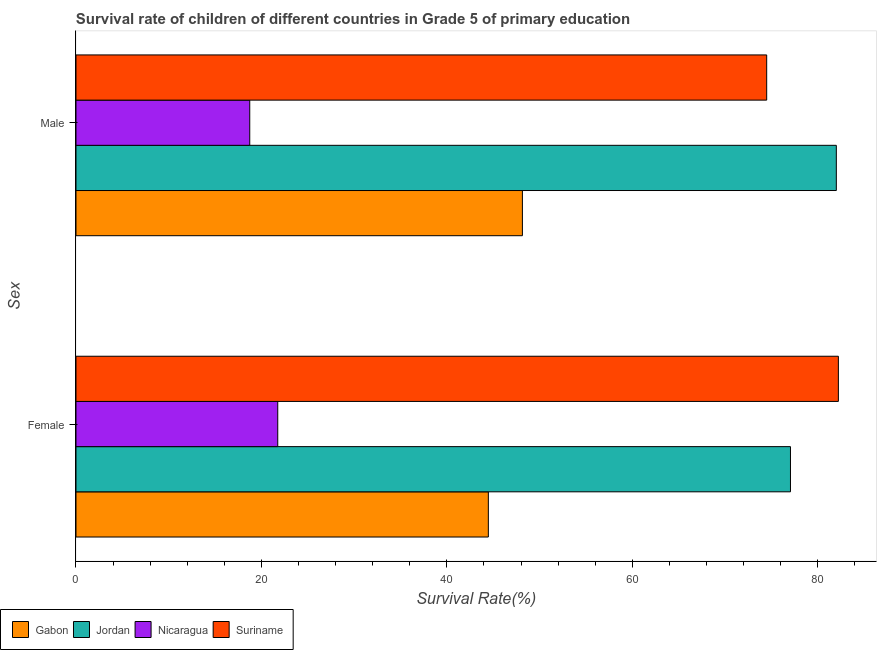How many groups of bars are there?
Provide a short and direct response. 2. Are the number of bars per tick equal to the number of legend labels?
Your answer should be very brief. Yes. Are the number of bars on each tick of the Y-axis equal?
Your response must be concise. Yes. How many bars are there on the 1st tick from the bottom?
Your response must be concise. 4. What is the survival rate of female students in primary education in Jordan?
Ensure brevity in your answer.  77.06. Across all countries, what is the maximum survival rate of male students in primary education?
Give a very brief answer. 82.01. Across all countries, what is the minimum survival rate of male students in primary education?
Keep it short and to the point. 18.74. In which country was the survival rate of male students in primary education maximum?
Give a very brief answer. Jordan. In which country was the survival rate of male students in primary education minimum?
Make the answer very short. Nicaragua. What is the total survival rate of male students in primary education in the graph?
Give a very brief answer. 223.4. What is the difference between the survival rate of male students in primary education in Gabon and that in Nicaragua?
Make the answer very short. 29.41. What is the difference between the survival rate of female students in primary education in Suriname and the survival rate of male students in primary education in Nicaragua?
Keep it short and to the point. 63.49. What is the average survival rate of female students in primary education per country?
Your response must be concise. 56.38. What is the difference between the survival rate of female students in primary education and survival rate of male students in primary education in Gabon?
Provide a short and direct response. -3.67. In how many countries, is the survival rate of female students in primary education greater than 28 %?
Ensure brevity in your answer.  3. What is the ratio of the survival rate of male students in primary education in Nicaragua to that in Suriname?
Ensure brevity in your answer.  0.25. In how many countries, is the survival rate of male students in primary education greater than the average survival rate of male students in primary education taken over all countries?
Provide a succinct answer. 2. What does the 1st bar from the top in Male represents?
Ensure brevity in your answer.  Suriname. What does the 4th bar from the bottom in Male represents?
Provide a short and direct response. Suriname. How many bars are there?
Your answer should be very brief. 8. Are all the bars in the graph horizontal?
Your answer should be compact. Yes. How many countries are there in the graph?
Your answer should be very brief. 4. What is the difference between two consecutive major ticks on the X-axis?
Ensure brevity in your answer.  20. Are the values on the major ticks of X-axis written in scientific E-notation?
Offer a very short reply. No. How many legend labels are there?
Provide a succinct answer. 4. What is the title of the graph?
Your response must be concise. Survival rate of children of different countries in Grade 5 of primary education. Does "Mongolia" appear as one of the legend labels in the graph?
Your response must be concise. No. What is the label or title of the X-axis?
Provide a succinct answer. Survival Rate(%). What is the label or title of the Y-axis?
Offer a very short reply. Sex. What is the Survival Rate(%) in Gabon in Female?
Keep it short and to the point. 44.48. What is the Survival Rate(%) in Jordan in Female?
Your answer should be compact. 77.06. What is the Survival Rate(%) in Nicaragua in Female?
Your answer should be very brief. 21.76. What is the Survival Rate(%) in Suriname in Female?
Keep it short and to the point. 82.23. What is the Survival Rate(%) in Gabon in Male?
Offer a terse response. 48.15. What is the Survival Rate(%) in Jordan in Male?
Your answer should be very brief. 82.01. What is the Survival Rate(%) in Nicaragua in Male?
Give a very brief answer. 18.74. What is the Survival Rate(%) in Suriname in Male?
Your response must be concise. 74.5. Across all Sex, what is the maximum Survival Rate(%) of Gabon?
Ensure brevity in your answer.  48.15. Across all Sex, what is the maximum Survival Rate(%) of Jordan?
Your answer should be very brief. 82.01. Across all Sex, what is the maximum Survival Rate(%) in Nicaragua?
Provide a short and direct response. 21.76. Across all Sex, what is the maximum Survival Rate(%) in Suriname?
Your answer should be compact. 82.23. Across all Sex, what is the minimum Survival Rate(%) of Gabon?
Keep it short and to the point. 44.48. Across all Sex, what is the minimum Survival Rate(%) in Jordan?
Offer a very short reply. 77.06. Across all Sex, what is the minimum Survival Rate(%) of Nicaragua?
Your response must be concise. 18.74. Across all Sex, what is the minimum Survival Rate(%) of Suriname?
Offer a terse response. 74.5. What is the total Survival Rate(%) in Gabon in the graph?
Provide a short and direct response. 92.62. What is the total Survival Rate(%) in Jordan in the graph?
Keep it short and to the point. 159.07. What is the total Survival Rate(%) in Nicaragua in the graph?
Keep it short and to the point. 40.5. What is the total Survival Rate(%) in Suriname in the graph?
Provide a short and direct response. 156.72. What is the difference between the Survival Rate(%) in Gabon in Female and that in Male?
Offer a very short reply. -3.67. What is the difference between the Survival Rate(%) in Jordan in Female and that in Male?
Your answer should be compact. -4.95. What is the difference between the Survival Rate(%) in Nicaragua in Female and that in Male?
Your response must be concise. 3.02. What is the difference between the Survival Rate(%) of Suriname in Female and that in Male?
Your answer should be compact. 7.73. What is the difference between the Survival Rate(%) in Gabon in Female and the Survival Rate(%) in Jordan in Male?
Keep it short and to the point. -37.53. What is the difference between the Survival Rate(%) of Gabon in Female and the Survival Rate(%) of Nicaragua in Male?
Your answer should be compact. 25.73. What is the difference between the Survival Rate(%) of Gabon in Female and the Survival Rate(%) of Suriname in Male?
Your answer should be very brief. -30.02. What is the difference between the Survival Rate(%) in Jordan in Female and the Survival Rate(%) in Nicaragua in Male?
Ensure brevity in your answer.  58.32. What is the difference between the Survival Rate(%) in Jordan in Female and the Survival Rate(%) in Suriname in Male?
Provide a short and direct response. 2.57. What is the difference between the Survival Rate(%) of Nicaragua in Female and the Survival Rate(%) of Suriname in Male?
Your answer should be compact. -52.73. What is the average Survival Rate(%) in Gabon per Sex?
Your response must be concise. 46.31. What is the average Survival Rate(%) in Jordan per Sex?
Provide a succinct answer. 79.54. What is the average Survival Rate(%) in Nicaragua per Sex?
Give a very brief answer. 20.25. What is the average Survival Rate(%) in Suriname per Sex?
Ensure brevity in your answer.  78.36. What is the difference between the Survival Rate(%) in Gabon and Survival Rate(%) in Jordan in Female?
Provide a succinct answer. -32.59. What is the difference between the Survival Rate(%) of Gabon and Survival Rate(%) of Nicaragua in Female?
Give a very brief answer. 22.71. What is the difference between the Survival Rate(%) in Gabon and Survival Rate(%) in Suriname in Female?
Ensure brevity in your answer.  -37.75. What is the difference between the Survival Rate(%) of Jordan and Survival Rate(%) of Nicaragua in Female?
Your response must be concise. 55.3. What is the difference between the Survival Rate(%) in Jordan and Survival Rate(%) in Suriname in Female?
Keep it short and to the point. -5.17. What is the difference between the Survival Rate(%) in Nicaragua and Survival Rate(%) in Suriname in Female?
Give a very brief answer. -60.47. What is the difference between the Survival Rate(%) of Gabon and Survival Rate(%) of Jordan in Male?
Offer a very short reply. -33.86. What is the difference between the Survival Rate(%) of Gabon and Survival Rate(%) of Nicaragua in Male?
Give a very brief answer. 29.41. What is the difference between the Survival Rate(%) of Gabon and Survival Rate(%) of Suriname in Male?
Make the answer very short. -26.35. What is the difference between the Survival Rate(%) of Jordan and Survival Rate(%) of Nicaragua in Male?
Provide a short and direct response. 63.27. What is the difference between the Survival Rate(%) of Jordan and Survival Rate(%) of Suriname in Male?
Your answer should be compact. 7.51. What is the difference between the Survival Rate(%) in Nicaragua and Survival Rate(%) in Suriname in Male?
Your response must be concise. -55.75. What is the ratio of the Survival Rate(%) of Gabon in Female to that in Male?
Provide a short and direct response. 0.92. What is the ratio of the Survival Rate(%) of Jordan in Female to that in Male?
Offer a terse response. 0.94. What is the ratio of the Survival Rate(%) of Nicaragua in Female to that in Male?
Ensure brevity in your answer.  1.16. What is the ratio of the Survival Rate(%) of Suriname in Female to that in Male?
Ensure brevity in your answer.  1.1. What is the difference between the highest and the second highest Survival Rate(%) of Gabon?
Ensure brevity in your answer.  3.67. What is the difference between the highest and the second highest Survival Rate(%) in Jordan?
Your answer should be very brief. 4.95. What is the difference between the highest and the second highest Survival Rate(%) in Nicaragua?
Offer a very short reply. 3.02. What is the difference between the highest and the second highest Survival Rate(%) in Suriname?
Provide a succinct answer. 7.73. What is the difference between the highest and the lowest Survival Rate(%) of Gabon?
Your answer should be very brief. 3.67. What is the difference between the highest and the lowest Survival Rate(%) in Jordan?
Offer a very short reply. 4.95. What is the difference between the highest and the lowest Survival Rate(%) in Nicaragua?
Make the answer very short. 3.02. What is the difference between the highest and the lowest Survival Rate(%) of Suriname?
Make the answer very short. 7.73. 